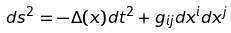<formula> <loc_0><loc_0><loc_500><loc_500>d s ^ { 2 } = - \Delta ( x ) d t ^ { 2 } + g _ { i j } d x ^ { i } d x ^ { j }</formula> 